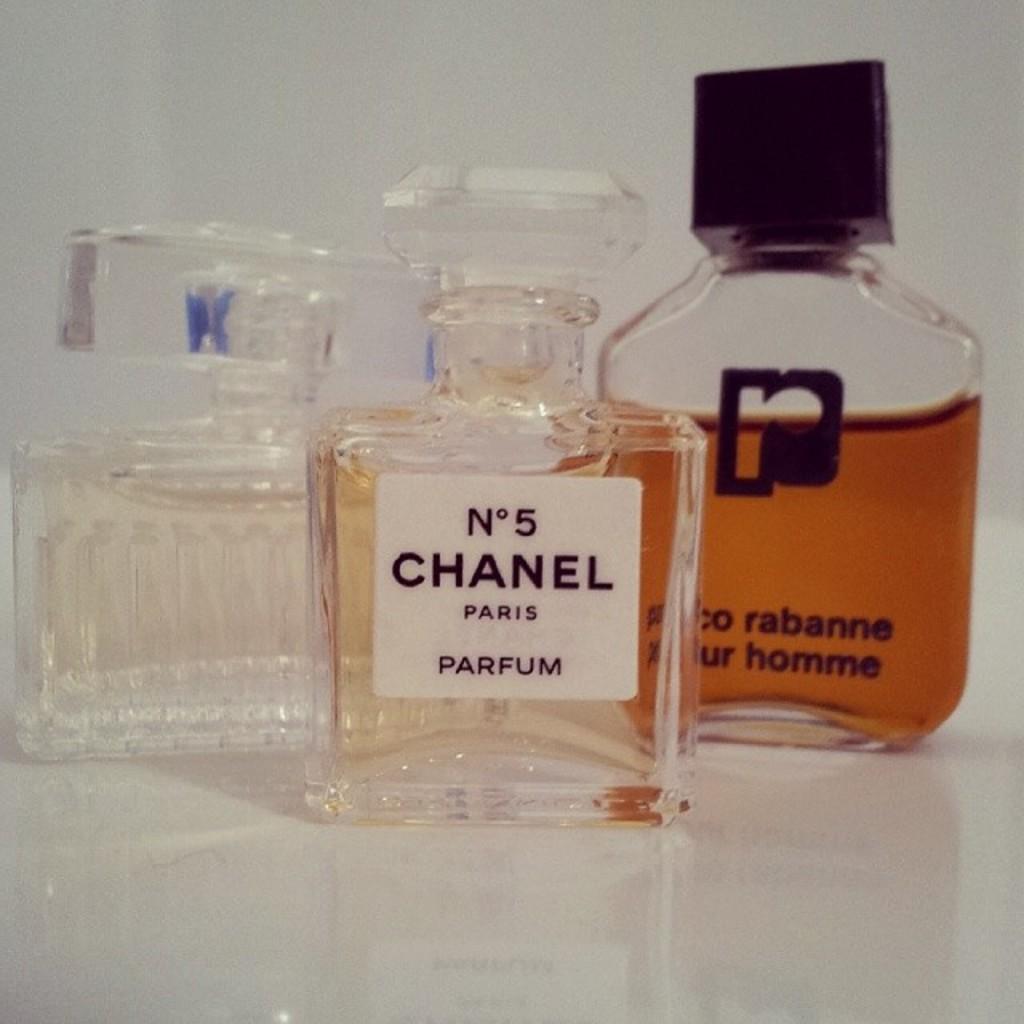Who makes n 5?
Offer a terse response. Chanel. What country is the middle perfume made in?
Give a very brief answer. France. 